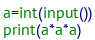Convert code to text. <code><loc_0><loc_0><loc_500><loc_500><_Python_>a=int(input())
print(a*a*a)
</code> 